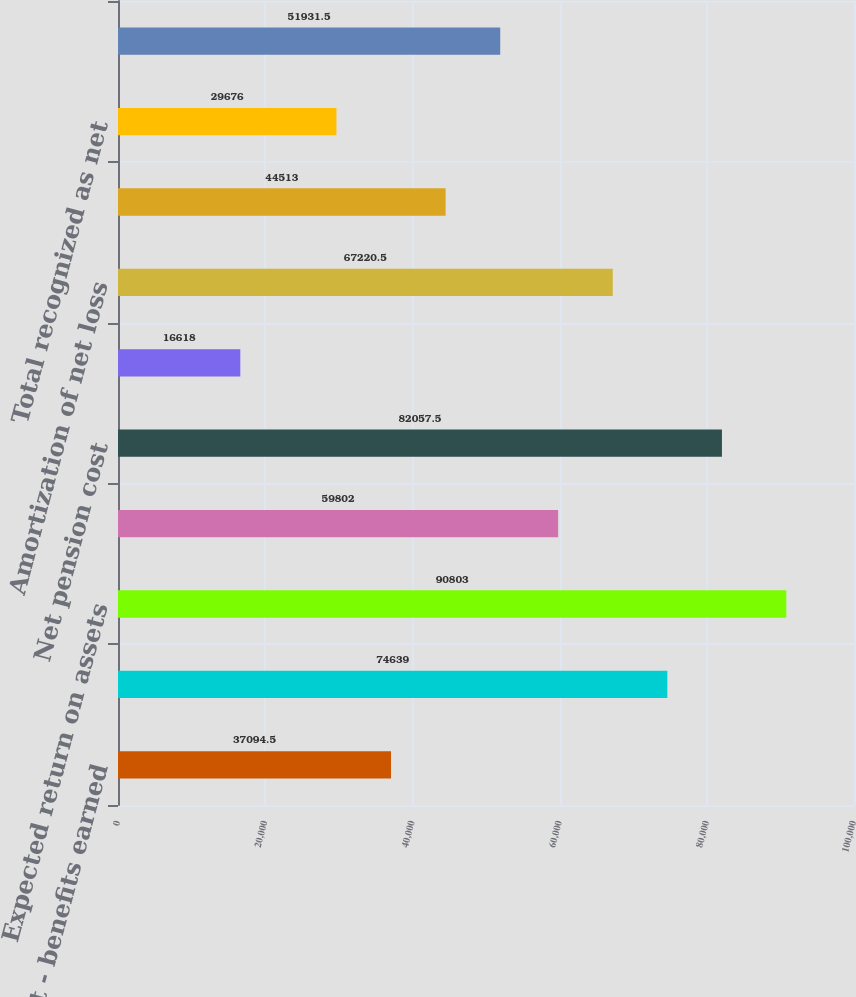<chart> <loc_0><loc_0><loc_500><loc_500><bar_chart><fcel>Service cost - benefits earned<fcel>Interest cost on projected<fcel>Expected return on assets<fcel>Recognized net loss<fcel>Net pension cost<fcel>Net (gain)/loss<fcel>Amortization of net loss<fcel>Total<fcel>Total recognized as net<fcel>Net loss<nl><fcel>37094.5<fcel>74639<fcel>90803<fcel>59802<fcel>82057.5<fcel>16618<fcel>67220.5<fcel>44513<fcel>29676<fcel>51931.5<nl></chart> 